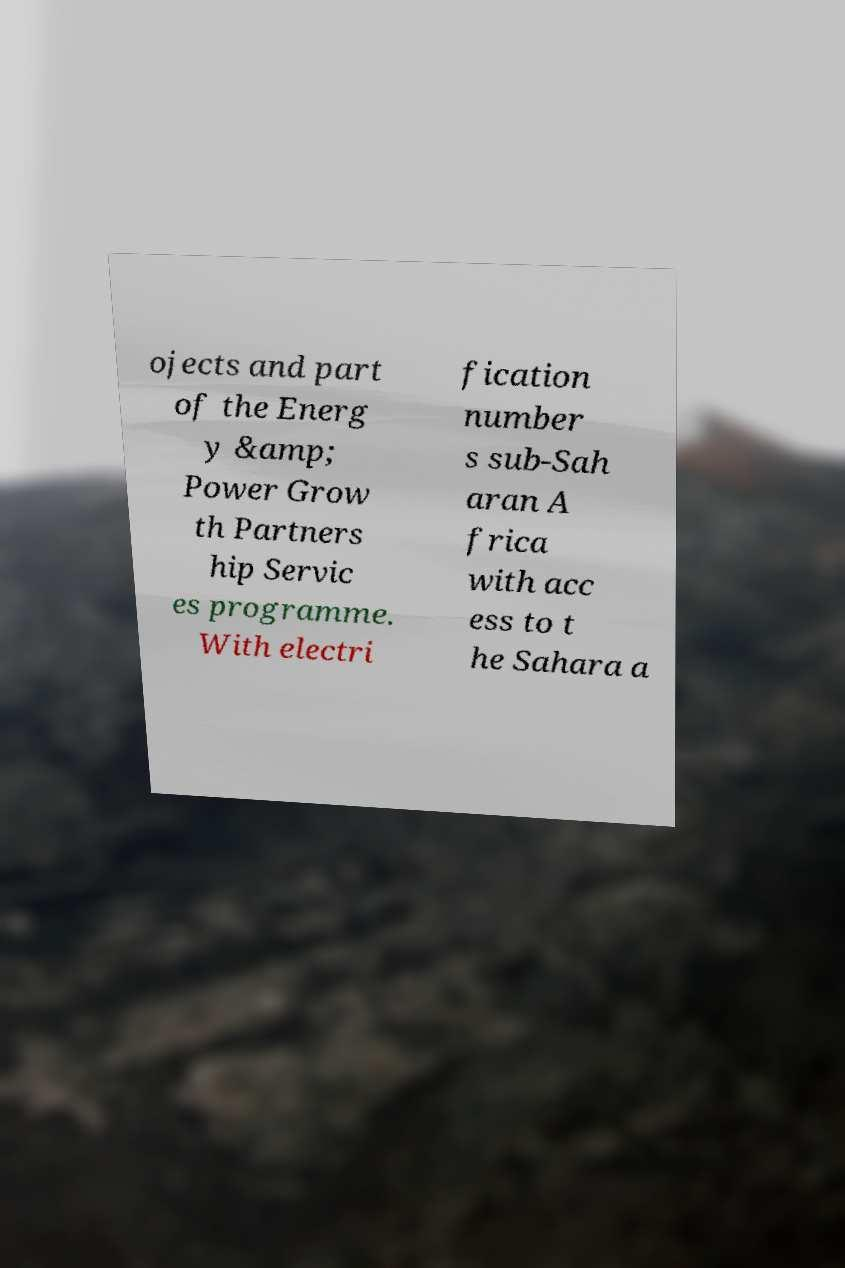Please read and relay the text visible in this image. What does it say? ojects and part of the Energ y &amp; Power Grow th Partners hip Servic es programme. With electri fication number s sub-Sah aran A frica with acc ess to t he Sahara a 